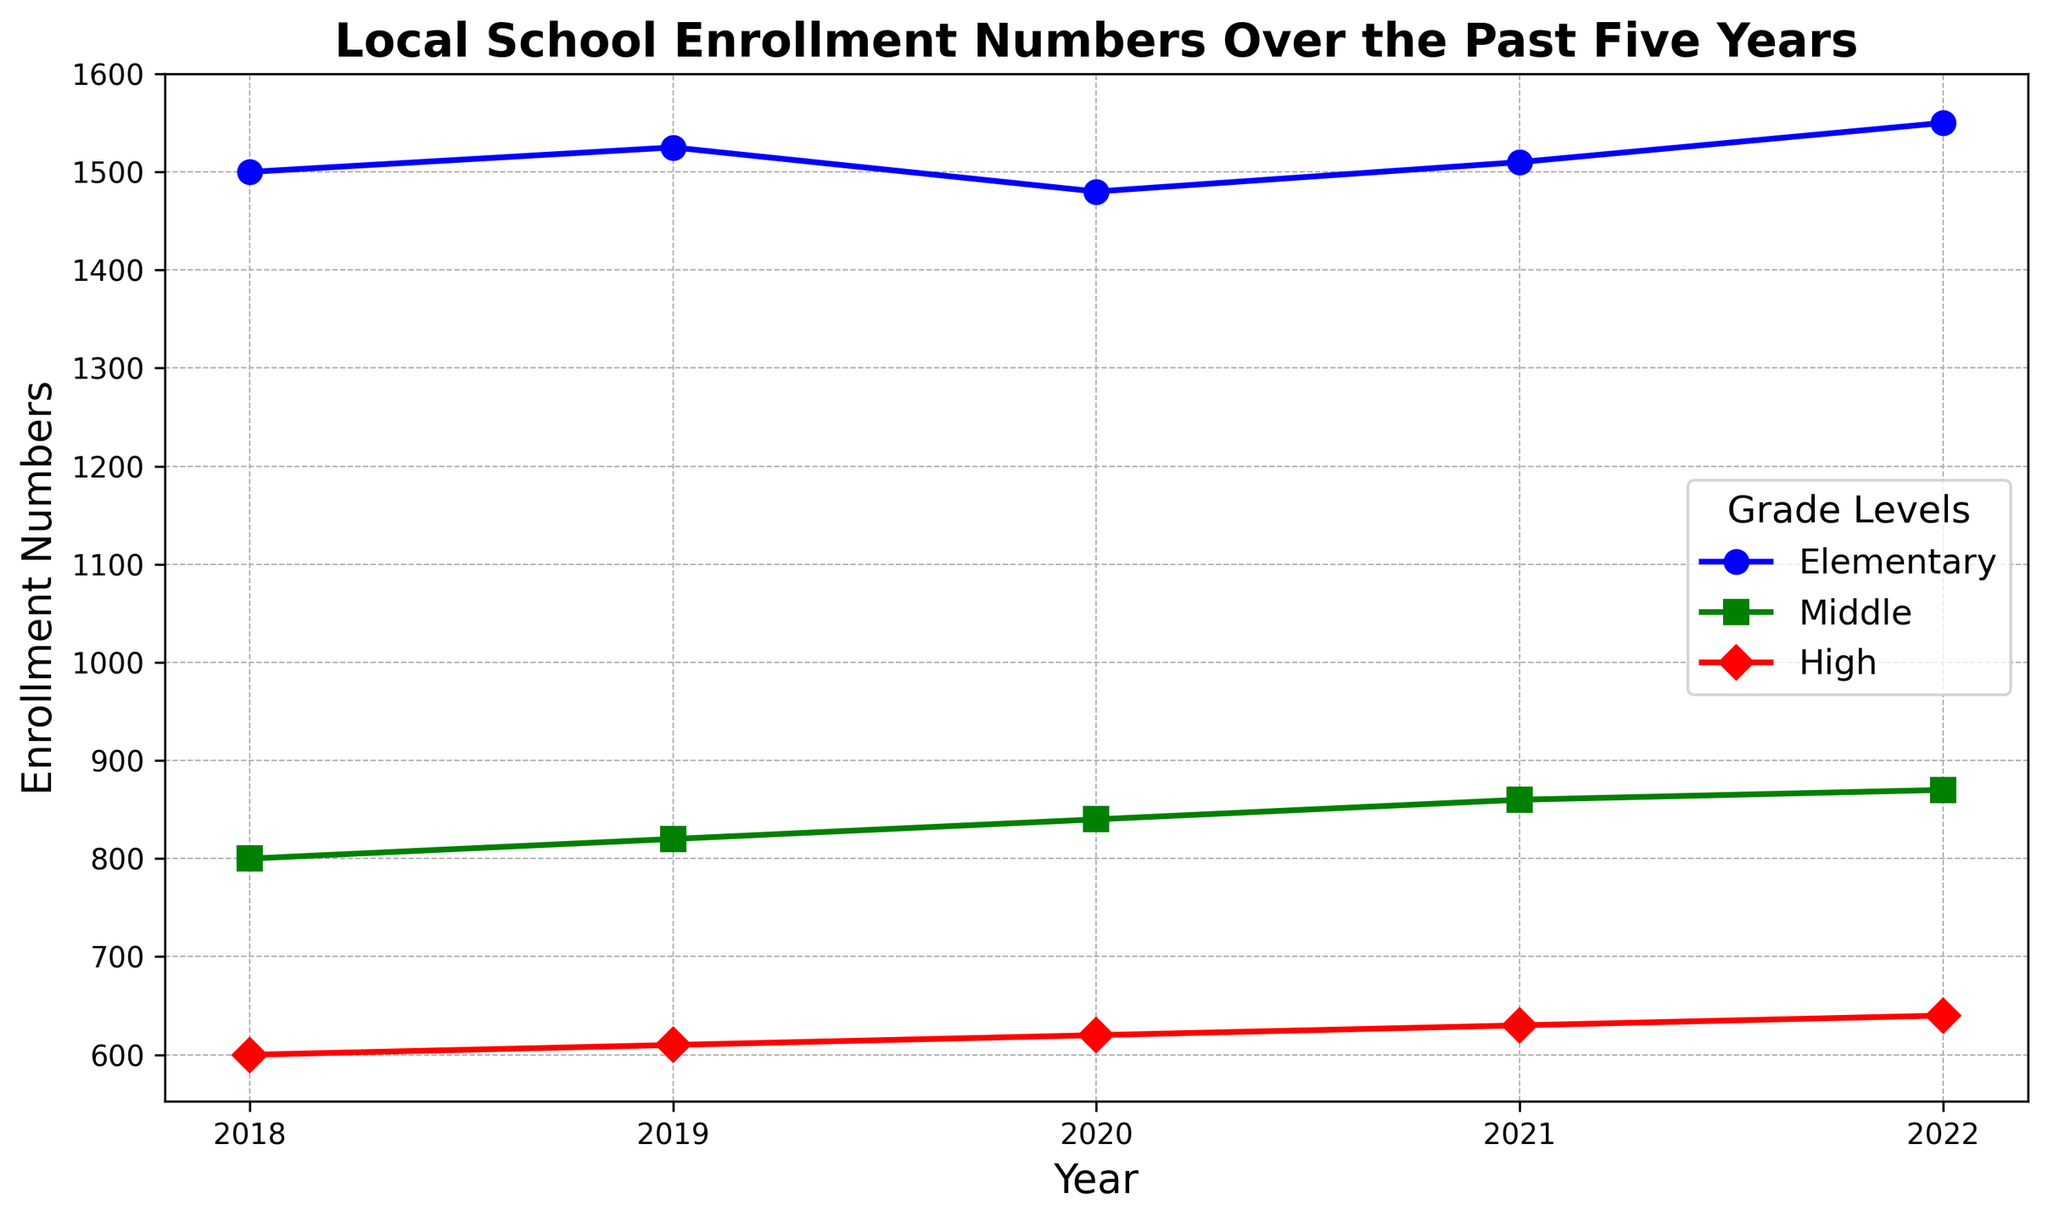What's the general trend in enrollment numbers for elementary schools over the past five years? The line for elementary school enrollment shows variability across the years 2018 to 2022, but overall, it ends higher in 2022 (1550) compared to its starting point in 2018 (1500).
Answer: Increasing Was there any year where middle school enrollment numbers did not increase compared to the previous year? By examining the line representing middle school enrollment, we see that the numbers increased each year from 2018 (800) to 2022 (870).
Answer: No Which grade level had the smallest increase in enrollment from 2018 to 2022? By comparing the differences in enrollment numbers for all grade levels from 2018 to 2022, we find: Elementary (1550 - 1500 = 50), Middle (870 - 800 = 70), and High (640 - 600 = 40). Therefore, High School had the smallest increase.
Answer: High In which year did the high school experience the highest enrollment number? Observing the line for high school enrollments, the highest point on the graph occurs in 2022 at 640 students.
Answer: 2022 What was the total enrollment for all grade levels in the year 2020? Summing up the enrollment numbers for all grade levels in 2020: Elementary (1480) + Middle (840) + High (620) = 2940.
Answer: 2940 Which grade level had the most stable enrollment numbers over the specified years? By looking at the variations in the lines, elementary and high school lines show more fluctuations, whereas the middle school line increases steadily each year, indicating stability.
Answer: Middle What is the average enrollment change per year for elementary schools from 2019 to 2022? First, find the changes each year: 2020 (1480 - 1525 = -45), 2021 (1510 - 1480 = 30), 2022 (1550 - 1510 = 40). Average change is (-45 + 30 + 40) / 3 = 25/3 ≈ 8.3.
Answer: 8.3 How does high school enrollment compare in 2022 to 2018? The high school enrollment increased from 600 in 2018 to 640 in 2022, which is an increase of 40.
Answer: Increase by 40 What visual markers are used to differentiate between middle and high school enrollment lines? Middle school enrollment is displayed with green lines and square markers, while high school enrollment uses red lines and diamond markers.
Answer: Green squares and red diamonds 